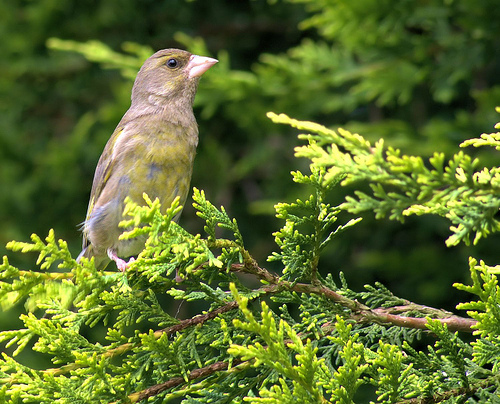What species of bird is this? This is a European Greenfinch. It's recognizable by its yellow-green plumage and the slightly forked tail. 